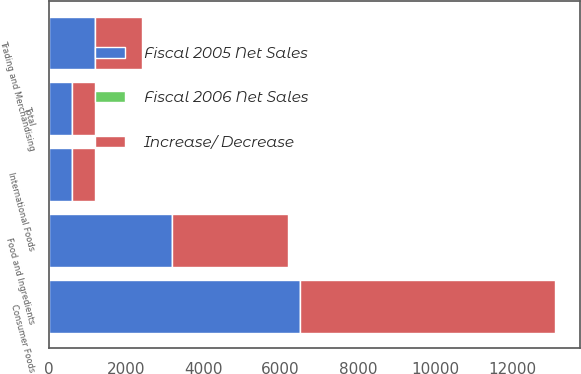Convert chart to OTSL. <chart><loc_0><loc_0><loc_500><loc_500><stacked_bar_chart><ecel><fcel>Consumer Foods<fcel>Food and Ingredients<fcel>Trading and Merchandising<fcel>International Foods<fcel>Total<nl><fcel>Fiscal 2005 Net Sales<fcel>6504<fcel>3189<fcel>1186<fcel>603<fcel>603<nl><fcel>Increase/ Decrease<fcel>6598<fcel>2986<fcel>1224<fcel>576<fcel>603<nl><fcel>Fiscal 2006 Net Sales<fcel>1<fcel>7<fcel>3<fcel>5<fcel>1<nl></chart> 